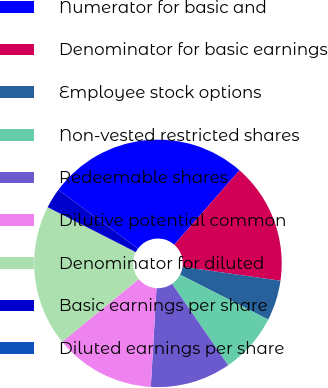Convert chart. <chart><loc_0><loc_0><loc_500><loc_500><pie_chart><fcel>Numerator for basic and<fcel>Denominator for basic earnings<fcel>Employee stock options<fcel>Non-vested restricted shares<fcel>Redeemable shares<fcel>Dilutive potential common<fcel>Denominator for diluted<fcel>Basic earnings per share<fcel>Diluted earnings per share<nl><fcel>26.32%<fcel>15.79%<fcel>5.26%<fcel>7.89%<fcel>10.53%<fcel>13.16%<fcel>18.42%<fcel>2.63%<fcel>0.0%<nl></chart> 